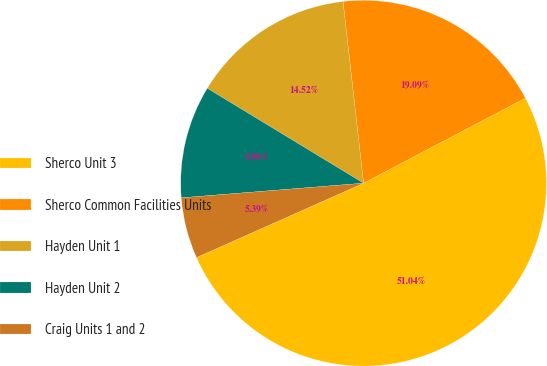Convert chart. <chart><loc_0><loc_0><loc_500><loc_500><pie_chart><fcel>Sherco Unit 3<fcel>Sherco Common Facilities Units<fcel>Hayden Unit 1<fcel>Hayden Unit 2<fcel>Craig Units 1 and 2<nl><fcel>51.04%<fcel>19.09%<fcel>14.52%<fcel>9.96%<fcel>5.39%<nl></chart> 